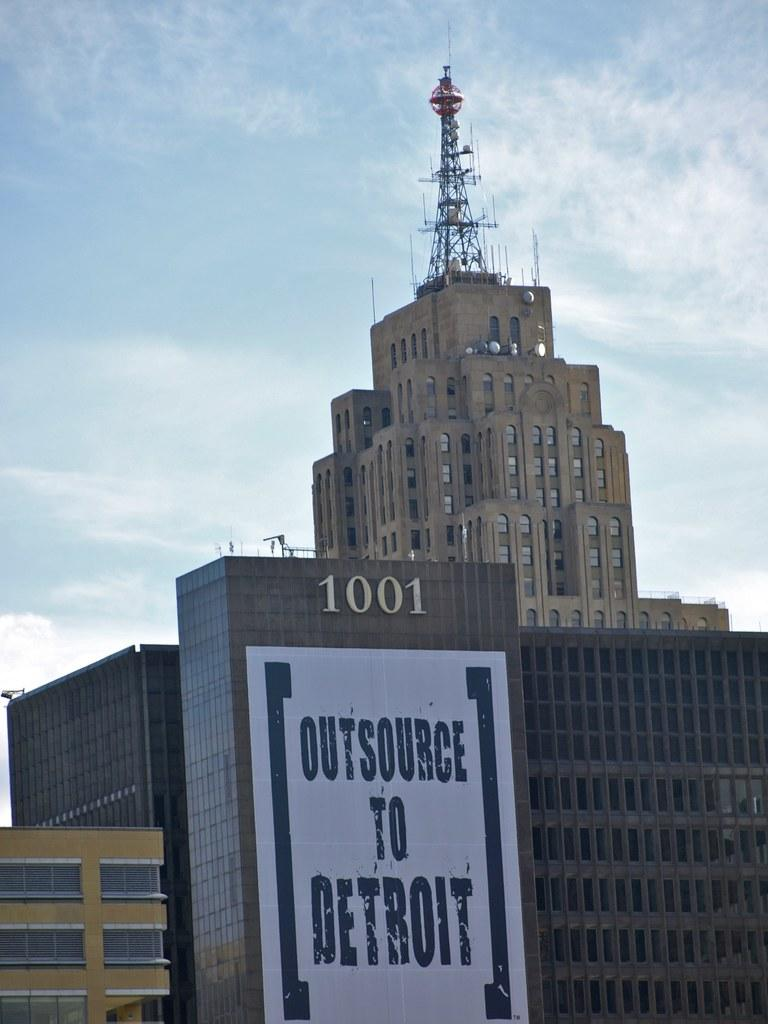What type of structures can be seen in the image? There are buildings in the image. Is there anything placed on any of the buildings? Yes, there is a board placed on one of the buildings. What can be seen in the background of the image? The sky is visible in the background of the image. Can you tell me how many hands are visible on the board in the image? There are no hands visible on the board in the image. The board is not related to a game of chess or any other activity involving hands. 